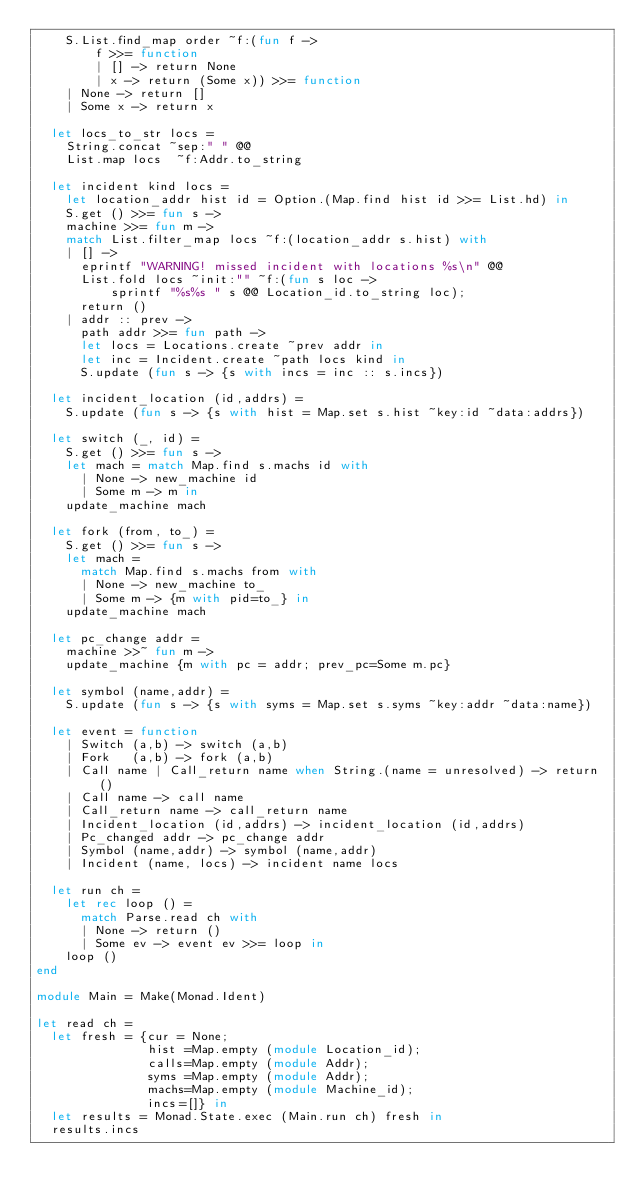<code> <loc_0><loc_0><loc_500><loc_500><_OCaml_>    S.List.find_map order ~f:(fun f ->
        f >>= function
        | [] -> return None
        | x -> return (Some x)) >>= function
    | None -> return []
    | Some x -> return x

  let locs_to_str locs =
    String.concat ~sep:" " @@
    List.map locs  ~f:Addr.to_string

  let incident kind locs =
    let location_addr hist id = Option.(Map.find hist id >>= List.hd) in
    S.get () >>= fun s ->
    machine >>= fun m ->
    match List.filter_map locs ~f:(location_addr s.hist) with
    | [] ->
      eprintf "WARNING! missed incident with locations %s\n" @@
      List.fold locs ~init:"" ~f:(fun s loc ->
          sprintf "%s%s " s @@ Location_id.to_string loc);
      return ()
    | addr :: prev ->
      path addr >>= fun path ->
      let locs = Locations.create ~prev addr in
      let inc = Incident.create ~path locs kind in
      S.update (fun s -> {s with incs = inc :: s.incs})

  let incident_location (id,addrs) =
    S.update (fun s -> {s with hist = Map.set s.hist ~key:id ~data:addrs})

  let switch (_, id) =
    S.get () >>= fun s ->
    let mach = match Map.find s.machs id with
      | None -> new_machine id
      | Some m -> m in
    update_machine mach

  let fork (from, to_) =
    S.get () >>= fun s ->
    let mach =
      match Map.find s.machs from with
      | None -> new_machine to_
      | Some m -> {m with pid=to_} in
    update_machine mach

  let pc_change addr =
    machine >>~ fun m ->
    update_machine {m with pc = addr; prev_pc=Some m.pc}

  let symbol (name,addr) =
    S.update (fun s -> {s with syms = Map.set s.syms ~key:addr ~data:name})

  let event = function
    | Switch (a,b) -> switch (a,b)
    | Fork   (a,b) -> fork (a,b)
    | Call name | Call_return name when String.(name = unresolved) -> return ()
    | Call name -> call name
    | Call_return name -> call_return name
    | Incident_location (id,addrs) -> incident_location (id,addrs)
    | Pc_changed addr -> pc_change addr
    | Symbol (name,addr) -> symbol (name,addr)
    | Incident (name, locs) -> incident name locs

  let run ch =
    let rec loop () =
      match Parse.read ch with
      | None -> return ()
      | Some ev -> event ev >>= loop in
    loop ()
end

module Main = Make(Monad.Ident)

let read ch =
  let fresh = {cur = None;
               hist =Map.empty (module Location_id);
               calls=Map.empty (module Addr);
               syms =Map.empty (module Addr);
               machs=Map.empty (module Machine_id);
               incs=[]} in
  let results = Monad.State.exec (Main.run ch) fresh in
  results.incs
</code> 